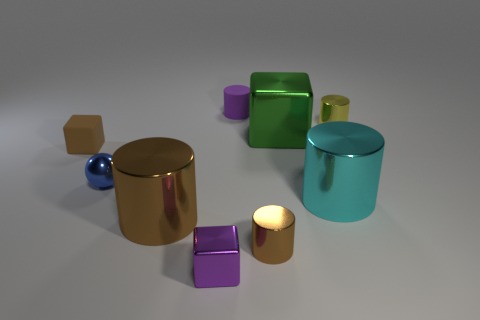Subtract 2 cylinders. How many cylinders are left? 3 Subtract all small rubber cylinders. How many cylinders are left? 4 Subtract all blue cylinders. Subtract all purple balls. How many cylinders are left? 5 Add 1 tiny gray shiny balls. How many objects exist? 10 Subtract all spheres. How many objects are left? 8 Add 9 blue balls. How many blue balls are left? 10 Add 3 tiny blue rubber cylinders. How many tiny blue rubber cylinders exist? 3 Subtract 0 gray cylinders. How many objects are left? 9 Subtract all tiny blocks. Subtract all rubber cylinders. How many objects are left? 6 